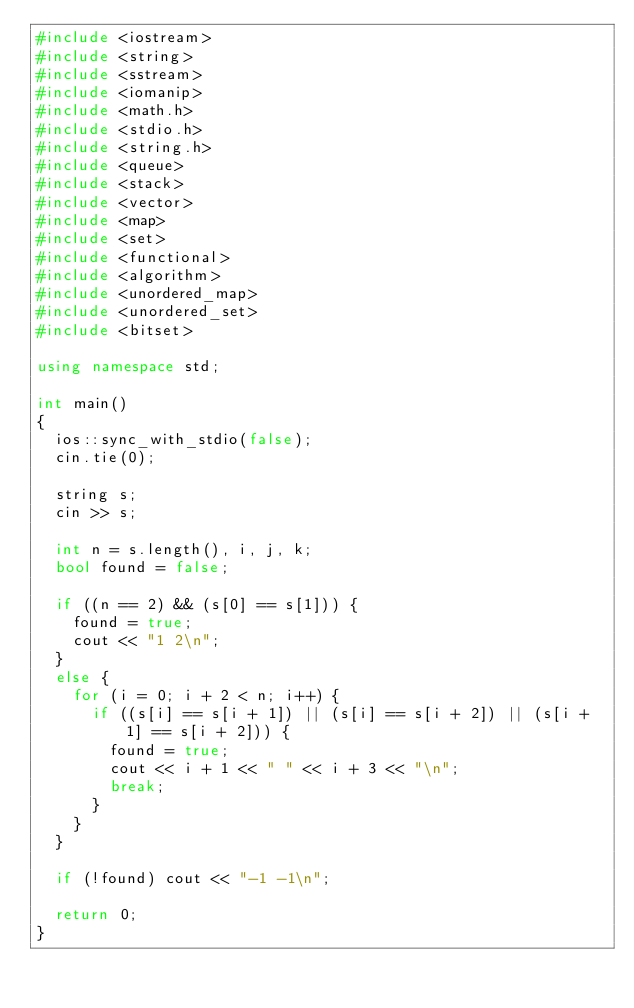Convert code to text. <code><loc_0><loc_0><loc_500><loc_500><_C++_>#include <iostream>
#include <string>
#include <sstream>
#include <iomanip> 
#include <math.h>
#include <stdio.h>
#include <string.h>
#include <queue>
#include <stack>
#include <vector>
#include <map>
#include <set>
#include <functional>
#include <algorithm>
#include <unordered_map>
#include <unordered_set>
#include <bitset>

using namespace std;

int main()
{
	ios::sync_with_stdio(false);
	cin.tie(0);
	
	string s;
	cin >> s;

	int n = s.length(), i, j, k;
	bool found = false;

	if ((n == 2) && (s[0] == s[1])) {
		found = true;
		cout << "1 2\n";
	}
	else {
		for (i = 0; i + 2 < n; i++) {
			if ((s[i] == s[i + 1]) || (s[i] == s[i + 2]) || (s[i + 1] == s[i + 2])) {
				found = true;
				cout << i + 1 << " " << i + 3 << "\n";
				break;
			}
		}
	}

	if (!found) cout << "-1 -1\n";

	return 0;
}
</code> 